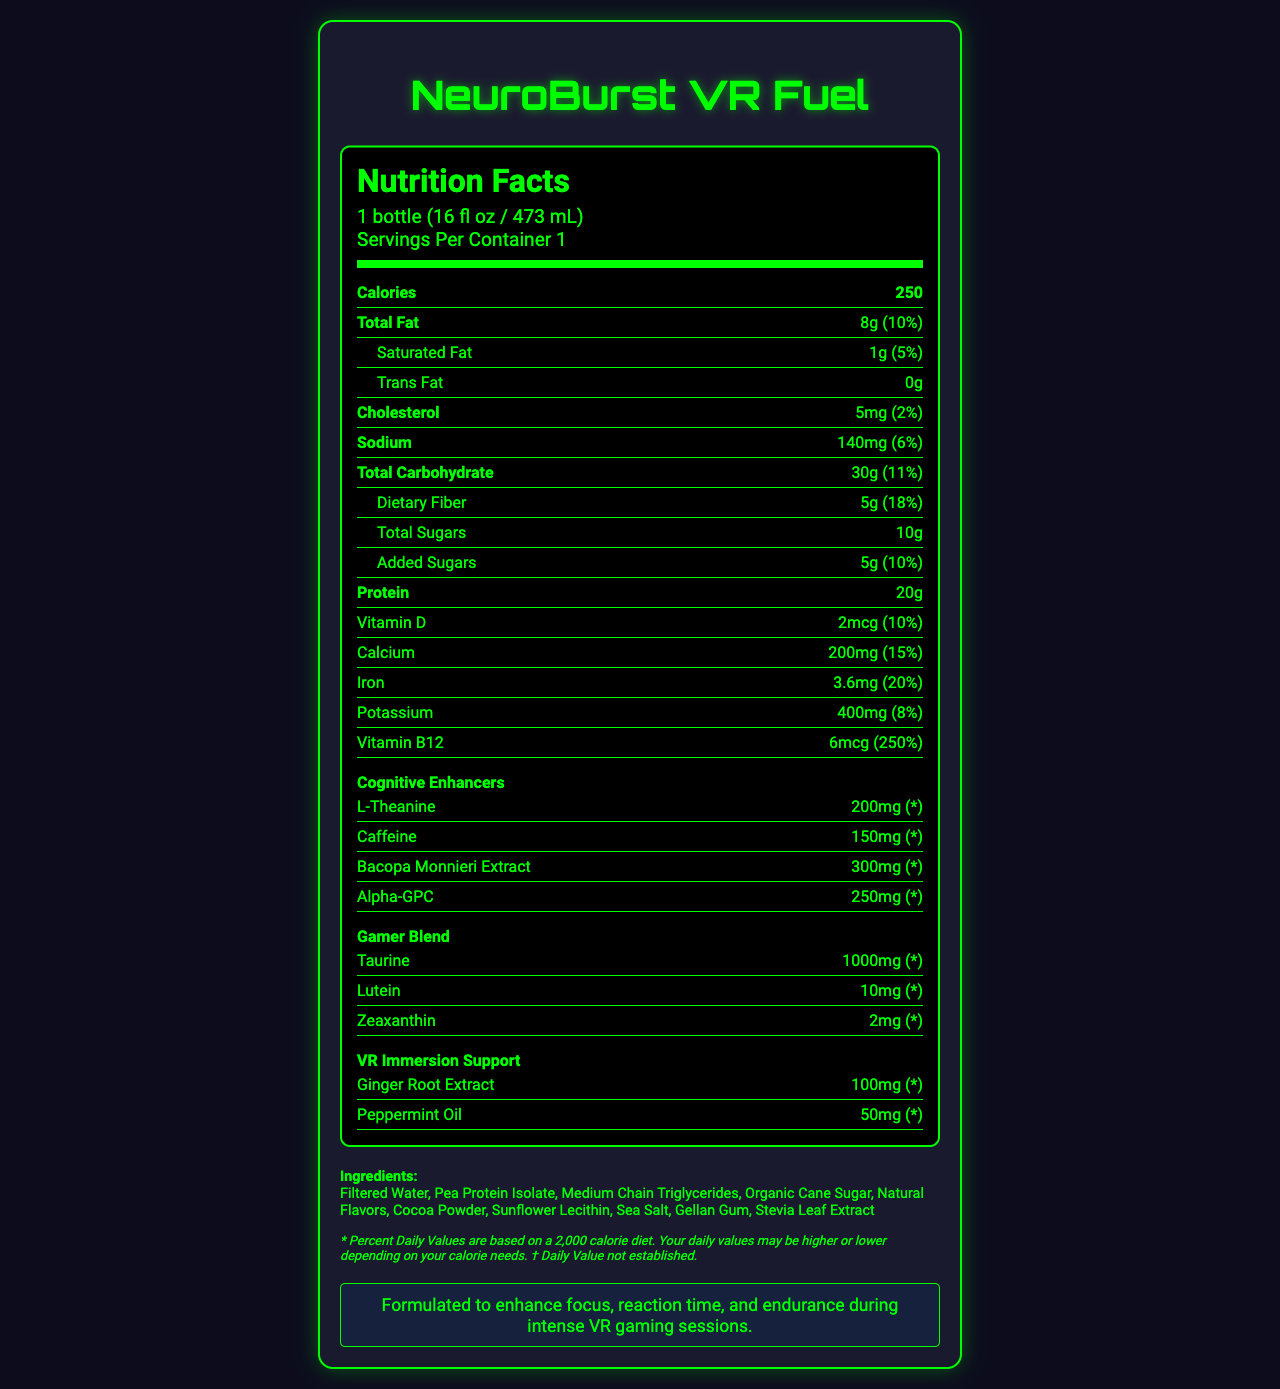what is the serving size for NeuroBurst VR Fuel? The serving size is clearly stated under the "Nutrition Facts" heading as "1 bottle (16 fl oz / 473 mL)".
Answer: 1 bottle (16 fl oz / 473 mL) how many calories are in one serving of NeuroBurst VR Fuel? The calories are listed in bold under the "Calories" section.
Answer: 250 what amount of protein does the shake contain per serving? The amount of protein is listed under the "Protein" section as 20g.
Answer: 20g how much Vitamin D is in NeuroBurst VR Fuel, and what is its daily value percentage? Under the Vitamin D section, it shows 2mcg and 10%.
Answer: 2mcg, 10% what are the three components listed under the "VR Immersion Support" blend? The "VR Immersion Support" section lists Ginger Root Extract (100mg) and Peppermint Oil (50mg).
Answer: Ginger Root Extract, Peppermint Oil what is the total amount of added sugars in the shake, and what daily value percentage does it represent? The “Added Sugars” section lists 5g and notes it as 10% of the daily value.
Answer: 5g, 10% does the NeuroBurst VR Fuel contain any allergens? If so, which ones? The allergen information states that it contains Coconut.
Answer: Yes, Coconut what is the main flavor of NeuroBurst VR Fuel? The flavor is listed on the document as "Chocolate Cyberspace Swirl".
Answer: Chocolate Cyberspace Swirl how does the product claim to support gaming performance? The claim can be found in the "gaming boost claim" section summarizing its benefits for gaming performance.
Answer: Formulated to enhance focus, reaction time, and endurance during intense VR gaming sessions which cognitive enhancer is present in the highest amount? A. L-Theanine B. Caffeine C. Bacopa Monnieri Extract D. Alpha-GPC Bacopa Monnieri Extract has the highest amount listed at 300mg.
Answer: C what is the added daily value percentage of Vitamin B12 in the NeuroBurst VR Fuel? I. 10% II. 50% III. 100% IV. 250% The document lists Vitamin B12 with a daily value percentage of 250%.
Answer: IV is there any trans fat in the NeuroBurst VR Fuel? The document lists "Trans Fat" as 0g, indicating there is no trans fat present.
Answer: No summarize the main features and nutritional highlights of NeuroBurst VR Fuel. The summary explains that the product is targeted at VR gamers and highlights the nutritional components and special ingredients meant to enhance gaming performance.
Answer: NeuroBurst VR Fuel is a meal replacement shake designed for VR gamers, combining nutrition with cognitive enhancers and gamer-specific ingredients. It provides 250 calories per serving, with 8g of total fat, 20g of protein, and a selection of vitamins and minerals such as Vitamin D, Calcium, Iron, and Vitamin B12. The shake also includes cognitive enhancers like L-Theanine, Caffeine, Bacopa Monnieri Extract, and ingredients for VR immersion support like Ginger Root Extract and Peppermint Oil. It is flavored as Chocolate Cyberspace Swirl and claims to boost focus, reaction time, and endurance during gaming sessions. what is the recommended storage condition for NeuroBurst VR Fuel? The storage instructions clearly state to keep the product refrigerated.
Answer: Keep refrigerated what are the exact daily value percentages for Iron and Calcium in the shake? The daily values are listed under their respective nutrient sections as Iron 20% and Calcium 15%.
Answer: Iron: 20%, Calcium: 15% does the document provide information on the exact ingredients used in the shake? It lists ingredients such as Filtered Water, Pea Protein Isolate, Medium Chain Triglycerides, Organic Cane Sugar, etc., under the "Ingredients" section.
Answer: Yes how many servings per container are mentioned for the NeuroBurst VR Fuel? The document states "Servings Per Container 1" under the serving information.
Answer: 1 how is the design of the document relevant to the product's theme? The document's design elements such as font styles, colors, and layout are not included in the provided data and code, so their relevance to the VR theme cannot be inferred.
Answer: Cannot be determined 